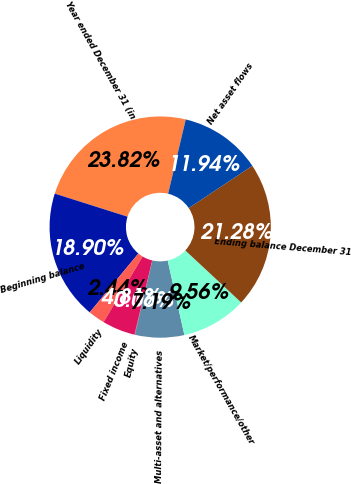<chart> <loc_0><loc_0><loc_500><loc_500><pie_chart><fcel>Year ended December 31 (in<fcel>Beginning balance<fcel>Liquidity<fcel>Fixed income<fcel>Equity<fcel>Multi-asset and alternatives<fcel>Market/performance/other<fcel>Ending balance December 31<fcel>Net asset flows<nl><fcel>23.82%<fcel>18.9%<fcel>2.44%<fcel>4.81%<fcel>0.06%<fcel>7.19%<fcel>9.56%<fcel>21.28%<fcel>11.94%<nl></chart> 